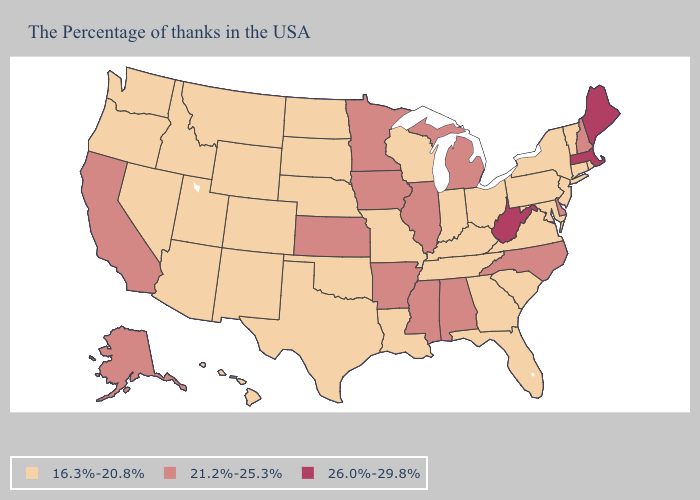Which states have the lowest value in the USA?
Write a very short answer. Rhode Island, Vermont, Connecticut, New York, New Jersey, Maryland, Pennsylvania, Virginia, South Carolina, Ohio, Florida, Georgia, Kentucky, Indiana, Tennessee, Wisconsin, Louisiana, Missouri, Nebraska, Oklahoma, Texas, South Dakota, North Dakota, Wyoming, Colorado, New Mexico, Utah, Montana, Arizona, Idaho, Nevada, Washington, Oregon, Hawaii. Name the states that have a value in the range 21.2%-25.3%?
Quick response, please. New Hampshire, Delaware, North Carolina, Michigan, Alabama, Illinois, Mississippi, Arkansas, Minnesota, Iowa, Kansas, California, Alaska. What is the highest value in states that border Pennsylvania?
Write a very short answer. 26.0%-29.8%. What is the highest value in the USA?
Be succinct. 26.0%-29.8%. What is the value of Washington?
Concise answer only. 16.3%-20.8%. Among the states that border Mississippi , does Tennessee have the highest value?
Give a very brief answer. No. What is the value of Alabama?
Keep it brief. 21.2%-25.3%. Which states have the highest value in the USA?
Quick response, please. Maine, Massachusetts, West Virginia. Does Maine have the highest value in the Northeast?
Be succinct. Yes. What is the value of Georgia?
Give a very brief answer. 16.3%-20.8%. Which states have the lowest value in the USA?
Short answer required. Rhode Island, Vermont, Connecticut, New York, New Jersey, Maryland, Pennsylvania, Virginia, South Carolina, Ohio, Florida, Georgia, Kentucky, Indiana, Tennessee, Wisconsin, Louisiana, Missouri, Nebraska, Oklahoma, Texas, South Dakota, North Dakota, Wyoming, Colorado, New Mexico, Utah, Montana, Arizona, Idaho, Nevada, Washington, Oregon, Hawaii. What is the value of Kentucky?
Quick response, please. 16.3%-20.8%. Does Idaho have a higher value than Kentucky?
Write a very short answer. No. What is the value of North Dakota?
Concise answer only. 16.3%-20.8%. What is the lowest value in states that border Indiana?
Quick response, please. 16.3%-20.8%. 